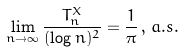<formula> <loc_0><loc_0><loc_500><loc_500>\lim _ { n \to \infty } \frac { T _ { n } ^ { X } } { ( \log n ) ^ { 2 } } = \frac { 1 } { \pi } \, , \, a . s .</formula> 